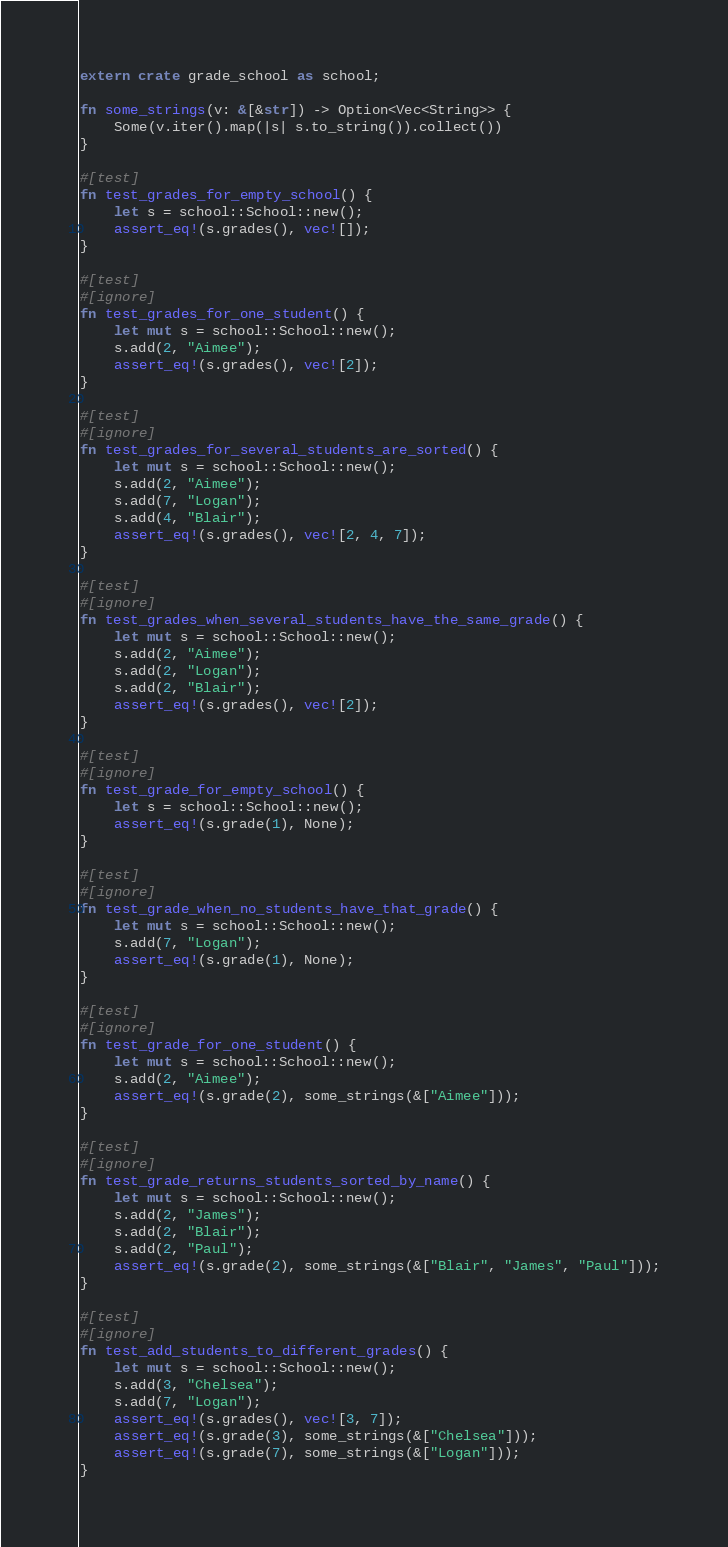Convert code to text. <code><loc_0><loc_0><loc_500><loc_500><_Rust_>extern crate grade_school as school;

fn some_strings(v: &[&str]) -> Option<Vec<String>> {
    Some(v.iter().map(|s| s.to_string()).collect())
}

#[test]
fn test_grades_for_empty_school() {
    let s = school::School::new();
    assert_eq!(s.grades(), vec![]);
}

#[test]
#[ignore]
fn test_grades_for_one_student() {
    let mut s = school::School::new();
    s.add(2, "Aimee");
    assert_eq!(s.grades(), vec![2]);
}

#[test]
#[ignore]
fn test_grades_for_several_students_are_sorted() {
    let mut s = school::School::new();
    s.add(2, "Aimee");
    s.add(7, "Logan");
    s.add(4, "Blair");
    assert_eq!(s.grades(), vec![2, 4, 7]);
}

#[test]
#[ignore]
fn test_grades_when_several_students_have_the_same_grade() {
    let mut s = school::School::new();
    s.add(2, "Aimee");
    s.add(2, "Logan");
    s.add(2, "Blair");
    assert_eq!(s.grades(), vec![2]);
}

#[test]
#[ignore]
fn test_grade_for_empty_school() {
    let s = school::School::new();
    assert_eq!(s.grade(1), None);
}

#[test]
#[ignore]
fn test_grade_when_no_students_have_that_grade() {
    let mut s = school::School::new();
    s.add(7, "Logan");
    assert_eq!(s.grade(1), None);
}

#[test]
#[ignore]
fn test_grade_for_one_student() {
    let mut s = school::School::new();
    s.add(2, "Aimee");
    assert_eq!(s.grade(2), some_strings(&["Aimee"]));
}

#[test]
#[ignore]
fn test_grade_returns_students_sorted_by_name() {
    let mut s = school::School::new();
    s.add(2, "James");
    s.add(2, "Blair");
    s.add(2, "Paul");
    assert_eq!(s.grade(2), some_strings(&["Blair", "James", "Paul"]));
}

#[test]
#[ignore]
fn test_add_students_to_different_grades() {
    let mut s = school::School::new();
    s.add(3, "Chelsea");
    s.add(7, "Logan");
    assert_eq!(s.grades(), vec![3, 7]);
    assert_eq!(s.grade(3), some_strings(&["Chelsea"]));
    assert_eq!(s.grade(7), some_strings(&["Logan"]));
}
</code> 